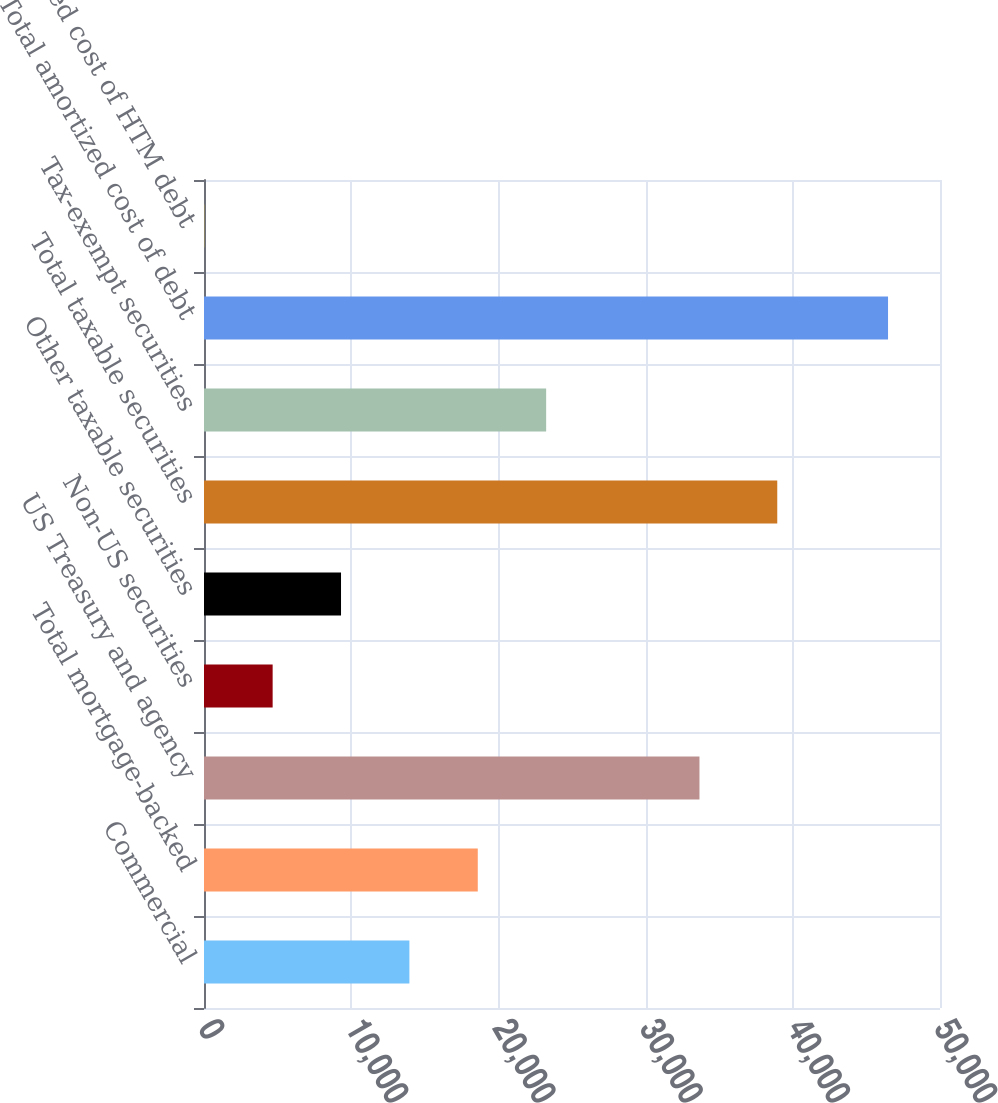Convert chart. <chart><loc_0><loc_0><loc_500><loc_500><bar_chart><fcel>Commercial<fcel>Total mortgage-backed<fcel>US Treasury and agency<fcel>Non-US securities<fcel>Other taxable securities<fcel>Total taxable securities<fcel>Tax-exempt securities<fcel>Total amortized cost of debt<fcel>Amortized cost of HTM debt<nl><fcel>13953.6<fcel>18598.8<fcel>33659<fcel>4663.2<fcel>9308.4<fcel>38944<fcel>23244<fcel>46470<fcel>18<nl></chart> 